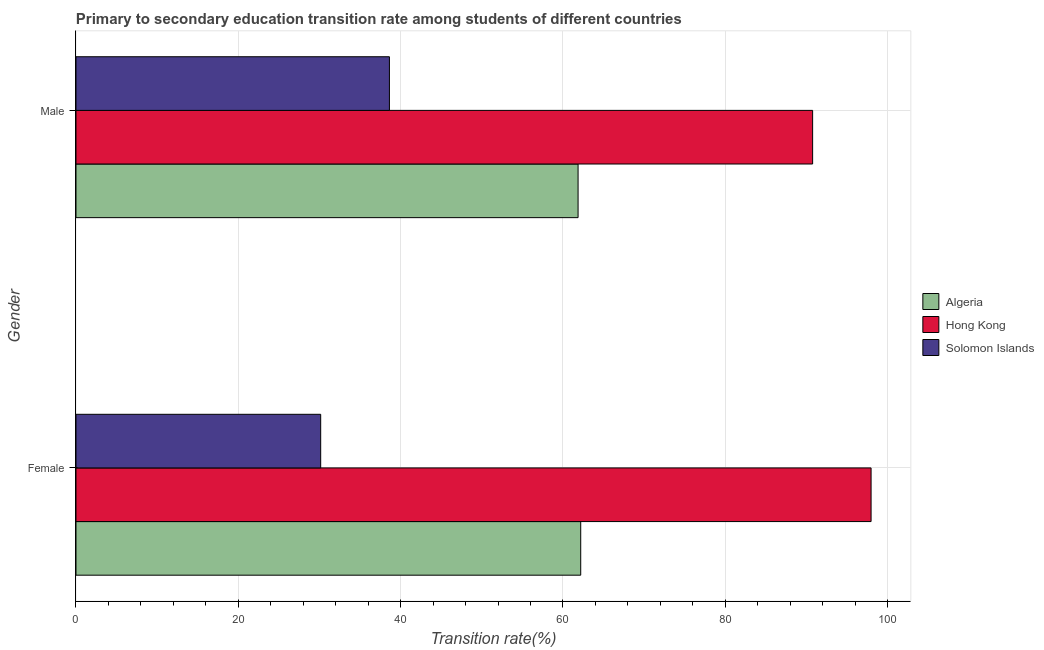How many different coloured bars are there?
Your response must be concise. 3. How many groups of bars are there?
Your answer should be very brief. 2. How many bars are there on the 1st tick from the top?
Your response must be concise. 3. What is the label of the 1st group of bars from the top?
Your response must be concise. Male. What is the transition rate among male students in Solomon Islands?
Make the answer very short. 38.62. Across all countries, what is the maximum transition rate among female students?
Keep it short and to the point. 97.96. Across all countries, what is the minimum transition rate among female students?
Make the answer very short. 30.15. In which country was the transition rate among male students maximum?
Your response must be concise. Hong Kong. In which country was the transition rate among female students minimum?
Provide a short and direct response. Solomon Islands. What is the total transition rate among female students in the graph?
Give a very brief answer. 190.29. What is the difference between the transition rate among male students in Algeria and that in Hong Kong?
Provide a short and direct response. -28.9. What is the difference between the transition rate among male students in Algeria and the transition rate among female students in Solomon Islands?
Provide a succinct answer. 31.71. What is the average transition rate among female students per country?
Ensure brevity in your answer.  63.43. What is the difference between the transition rate among male students and transition rate among female students in Hong Kong?
Give a very brief answer. -7.2. In how many countries, is the transition rate among female students greater than 32 %?
Your response must be concise. 2. What is the ratio of the transition rate among female students in Algeria to that in Hong Kong?
Your answer should be very brief. 0.63. Is the transition rate among male students in Algeria less than that in Hong Kong?
Make the answer very short. Yes. What does the 2nd bar from the top in Female represents?
Your answer should be compact. Hong Kong. What does the 1st bar from the bottom in Male represents?
Offer a very short reply. Algeria. Are the values on the major ticks of X-axis written in scientific E-notation?
Offer a very short reply. No. Does the graph contain grids?
Provide a short and direct response. Yes. How many legend labels are there?
Ensure brevity in your answer.  3. How are the legend labels stacked?
Give a very brief answer. Vertical. What is the title of the graph?
Keep it short and to the point. Primary to secondary education transition rate among students of different countries. What is the label or title of the X-axis?
Offer a terse response. Transition rate(%). What is the Transition rate(%) in Algeria in Female?
Provide a short and direct response. 62.18. What is the Transition rate(%) of Hong Kong in Female?
Ensure brevity in your answer.  97.96. What is the Transition rate(%) of Solomon Islands in Female?
Offer a terse response. 30.15. What is the Transition rate(%) in Algeria in Male?
Your answer should be very brief. 61.86. What is the Transition rate(%) of Hong Kong in Male?
Your response must be concise. 90.76. What is the Transition rate(%) in Solomon Islands in Male?
Provide a short and direct response. 38.62. Across all Gender, what is the maximum Transition rate(%) in Algeria?
Keep it short and to the point. 62.18. Across all Gender, what is the maximum Transition rate(%) in Hong Kong?
Make the answer very short. 97.96. Across all Gender, what is the maximum Transition rate(%) in Solomon Islands?
Offer a terse response. 38.62. Across all Gender, what is the minimum Transition rate(%) in Algeria?
Offer a terse response. 61.86. Across all Gender, what is the minimum Transition rate(%) in Hong Kong?
Offer a very short reply. 90.76. Across all Gender, what is the minimum Transition rate(%) of Solomon Islands?
Your answer should be very brief. 30.15. What is the total Transition rate(%) in Algeria in the graph?
Give a very brief answer. 124.04. What is the total Transition rate(%) in Hong Kong in the graph?
Your answer should be very brief. 188.71. What is the total Transition rate(%) of Solomon Islands in the graph?
Give a very brief answer. 68.76. What is the difference between the Transition rate(%) in Algeria in Female and that in Male?
Offer a very short reply. 0.33. What is the difference between the Transition rate(%) of Hong Kong in Female and that in Male?
Offer a terse response. 7.2. What is the difference between the Transition rate(%) in Solomon Islands in Female and that in Male?
Keep it short and to the point. -8.47. What is the difference between the Transition rate(%) in Algeria in Female and the Transition rate(%) in Hong Kong in Male?
Offer a terse response. -28.57. What is the difference between the Transition rate(%) of Algeria in Female and the Transition rate(%) of Solomon Islands in Male?
Keep it short and to the point. 23.57. What is the difference between the Transition rate(%) in Hong Kong in Female and the Transition rate(%) in Solomon Islands in Male?
Make the answer very short. 59.34. What is the average Transition rate(%) of Algeria per Gender?
Ensure brevity in your answer.  62.02. What is the average Transition rate(%) in Hong Kong per Gender?
Your answer should be compact. 94.36. What is the average Transition rate(%) of Solomon Islands per Gender?
Provide a succinct answer. 34.38. What is the difference between the Transition rate(%) in Algeria and Transition rate(%) in Hong Kong in Female?
Your answer should be compact. -35.77. What is the difference between the Transition rate(%) of Algeria and Transition rate(%) of Solomon Islands in Female?
Offer a terse response. 32.04. What is the difference between the Transition rate(%) in Hong Kong and Transition rate(%) in Solomon Islands in Female?
Keep it short and to the point. 67.81. What is the difference between the Transition rate(%) of Algeria and Transition rate(%) of Hong Kong in Male?
Your answer should be compact. -28.9. What is the difference between the Transition rate(%) of Algeria and Transition rate(%) of Solomon Islands in Male?
Offer a very short reply. 23.24. What is the difference between the Transition rate(%) of Hong Kong and Transition rate(%) of Solomon Islands in Male?
Offer a terse response. 52.14. What is the ratio of the Transition rate(%) of Hong Kong in Female to that in Male?
Provide a short and direct response. 1.08. What is the ratio of the Transition rate(%) of Solomon Islands in Female to that in Male?
Your answer should be very brief. 0.78. What is the difference between the highest and the second highest Transition rate(%) in Algeria?
Your response must be concise. 0.33. What is the difference between the highest and the second highest Transition rate(%) of Hong Kong?
Ensure brevity in your answer.  7.2. What is the difference between the highest and the second highest Transition rate(%) of Solomon Islands?
Your answer should be very brief. 8.47. What is the difference between the highest and the lowest Transition rate(%) in Algeria?
Provide a short and direct response. 0.33. What is the difference between the highest and the lowest Transition rate(%) in Hong Kong?
Ensure brevity in your answer.  7.2. What is the difference between the highest and the lowest Transition rate(%) in Solomon Islands?
Ensure brevity in your answer.  8.47. 